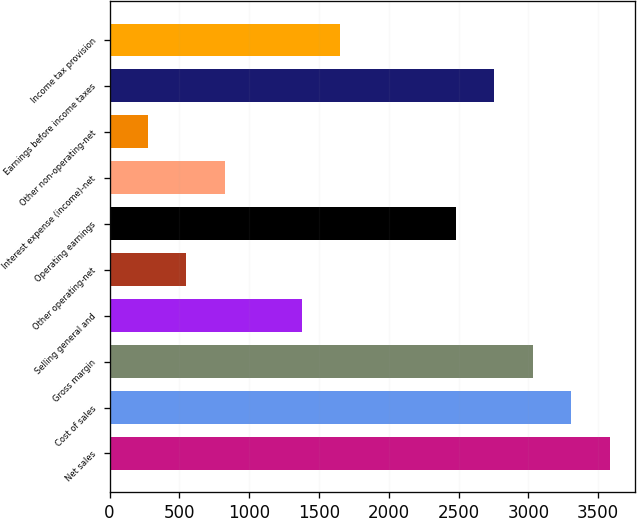<chart> <loc_0><loc_0><loc_500><loc_500><bar_chart><fcel>Net sales<fcel>Cost of sales<fcel>Gross margin<fcel>Selling general and<fcel>Other operating-net<fcel>Operating earnings<fcel>Interest expense (income)-net<fcel>Other non-operating-net<fcel>Earnings before income taxes<fcel>Income tax provision<nl><fcel>3583.66<fcel>3308<fcel>3032.34<fcel>1378.38<fcel>551.4<fcel>2481.02<fcel>827.06<fcel>275.74<fcel>2756.68<fcel>1654.04<nl></chart> 